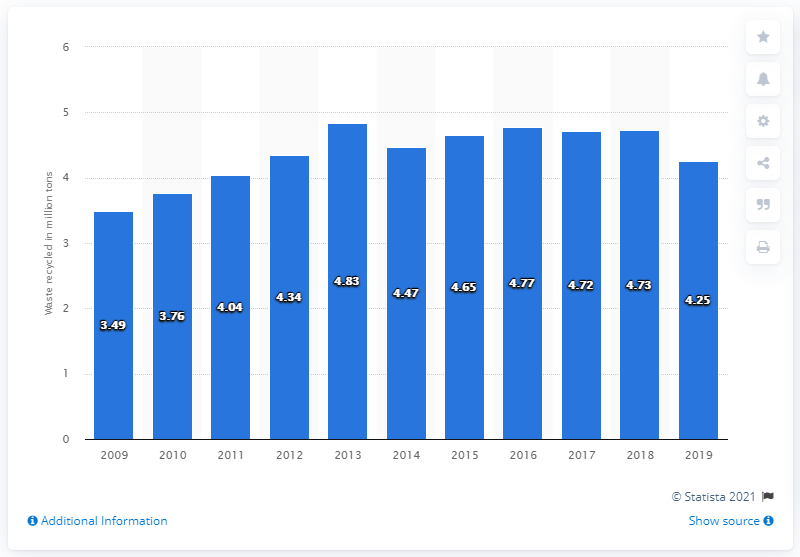Identify some key points in this picture. In 2019, Singapore recycled a total of 4.25 million metric tons of waste. 